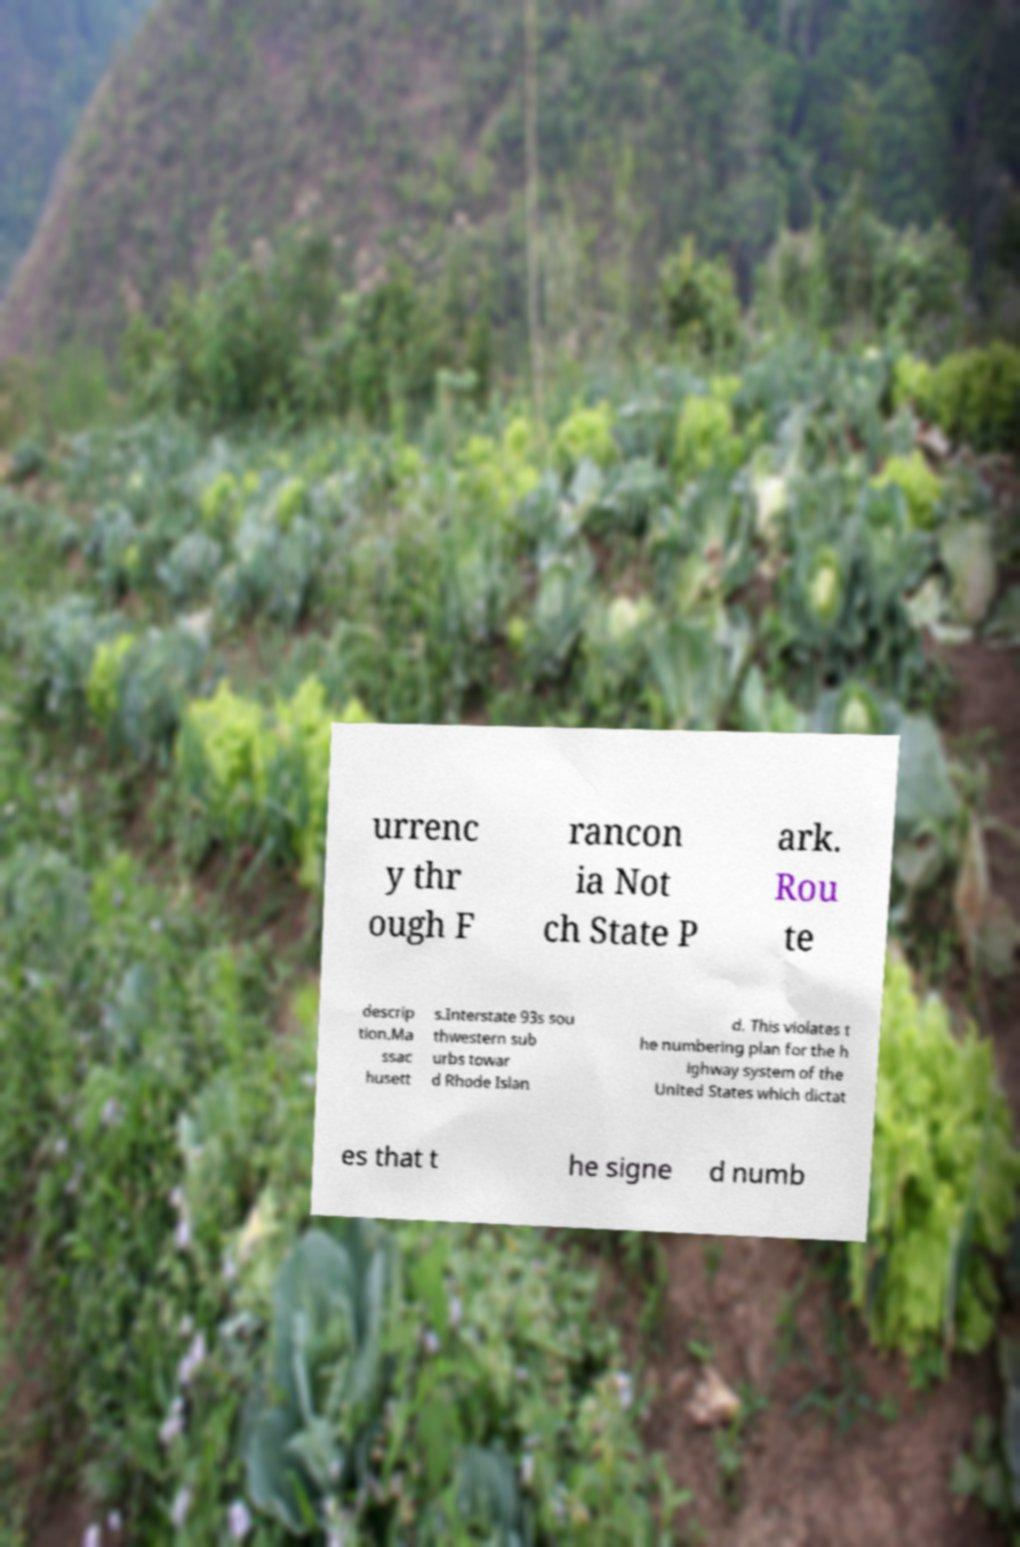Please read and relay the text visible in this image. What does it say? urrenc y thr ough F rancon ia Not ch State P ark. Rou te descrip tion.Ma ssac husett s.Interstate 93s sou thwestern sub urbs towar d Rhode Islan d. This violates t he numbering plan for the h ighway system of the United States which dictat es that t he signe d numb 